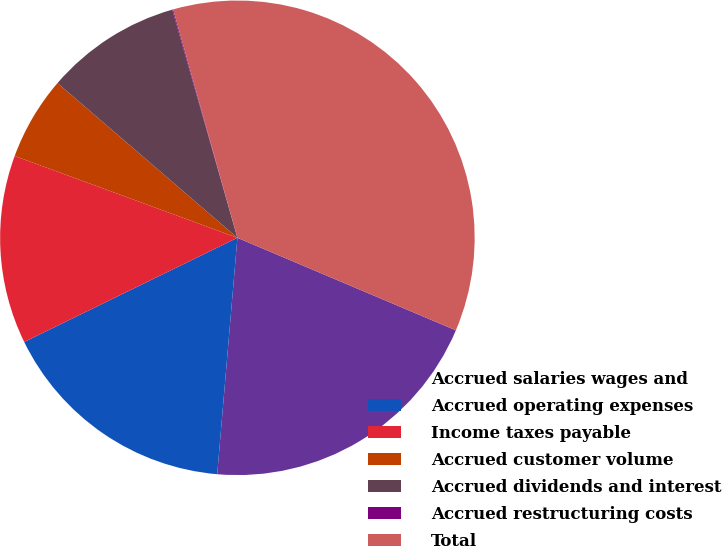<chart> <loc_0><loc_0><loc_500><loc_500><pie_chart><fcel>Accrued salaries wages and<fcel>Accrued operating expenses<fcel>Income taxes payable<fcel>Accrued customer volume<fcel>Accrued dividends and interest<fcel>Accrued restructuring costs<fcel>Total<nl><fcel>19.98%<fcel>16.41%<fcel>12.84%<fcel>5.7%<fcel>9.27%<fcel>0.06%<fcel>35.74%<nl></chart> 